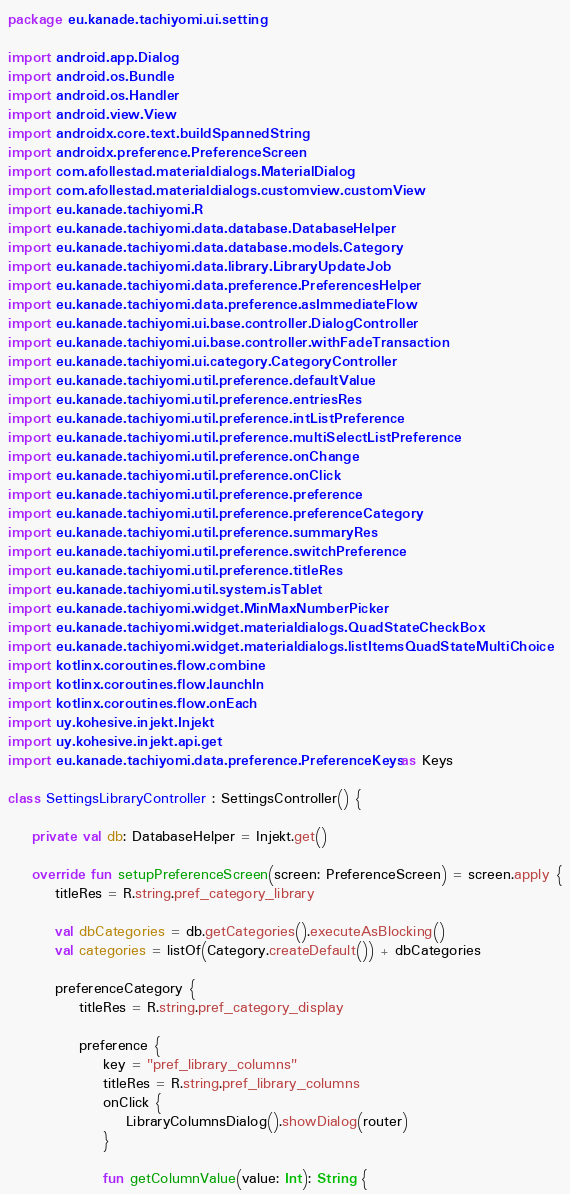Convert code to text. <code><loc_0><loc_0><loc_500><loc_500><_Kotlin_>package eu.kanade.tachiyomi.ui.setting

import android.app.Dialog
import android.os.Bundle
import android.os.Handler
import android.view.View
import androidx.core.text.buildSpannedString
import androidx.preference.PreferenceScreen
import com.afollestad.materialdialogs.MaterialDialog
import com.afollestad.materialdialogs.customview.customView
import eu.kanade.tachiyomi.R
import eu.kanade.tachiyomi.data.database.DatabaseHelper
import eu.kanade.tachiyomi.data.database.models.Category
import eu.kanade.tachiyomi.data.library.LibraryUpdateJob
import eu.kanade.tachiyomi.data.preference.PreferencesHelper
import eu.kanade.tachiyomi.data.preference.asImmediateFlow
import eu.kanade.tachiyomi.ui.base.controller.DialogController
import eu.kanade.tachiyomi.ui.base.controller.withFadeTransaction
import eu.kanade.tachiyomi.ui.category.CategoryController
import eu.kanade.tachiyomi.util.preference.defaultValue
import eu.kanade.tachiyomi.util.preference.entriesRes
import eu.kanade.tachiyomi.util.preference.intListPreference
import eu.kanade.tachiyomi.util.preference.multiSelectListPreference
import eu.kanade.tachiyomi.util.preference.onChange
import eu.kanade.tachiyomi.util.preference.onClick
import eu.kanade.tachiyomi.util.preference.preference
import eu.kanade.tachiyomi.util.preference.preferenceCategory
import eu.kanade.tachiyomi.util.preference.summaryRes
import eu.kanade.tachiyomi.util.preference.switchPreference
import eu.kanade.tachiyomi.util.preference.titleRes
import eu.kanade.tachiyomi.util.system.isTablet
import eu.kanade.tachiyomi.widget.MinMaxNumberPicker
import eu.kanade.tachiyomi.widget.materialdialogs.QuadStateCheckBox
import eu.kanade.tachiyomi.widget.materialdialogs.listItemsQuadStateMultiChoice
import kotlinx.coroutines.flow.combine
import kotlinx.coroutines.flow.launchIn
import kotlinx.coroutines.flow.onEach
import uy.kohesive.injekt.Injekt
import uy.kohesive.injekt.api.get
import eu.kanade.tachiyomi.data.preference.PreferenceKeys as Keys

class SettingsLibraryController : SettingsController() {

    private val db: DatabaseHelper = Injekt.get()

    override fun setupPreferenceScreen(screen: PreferenceScreen) = screen.apply {
        titleRes = R.string.pref_category_library

        val dbCategories = db.getCategories().executeAsBlocking()
        val categories = listOf(Category.createDefault()) + dbCategories

        preferenceCategory {
            titleRes = R.string.pref_category_display

            preference {
                key = "pref_library_columns"
                titleRes = R.string.pref_library_columns
                onClick {
                    LibraryColumnsDialog().showDialog(router)
                }

                fun getColumnValue(value: Int): String {</code> 